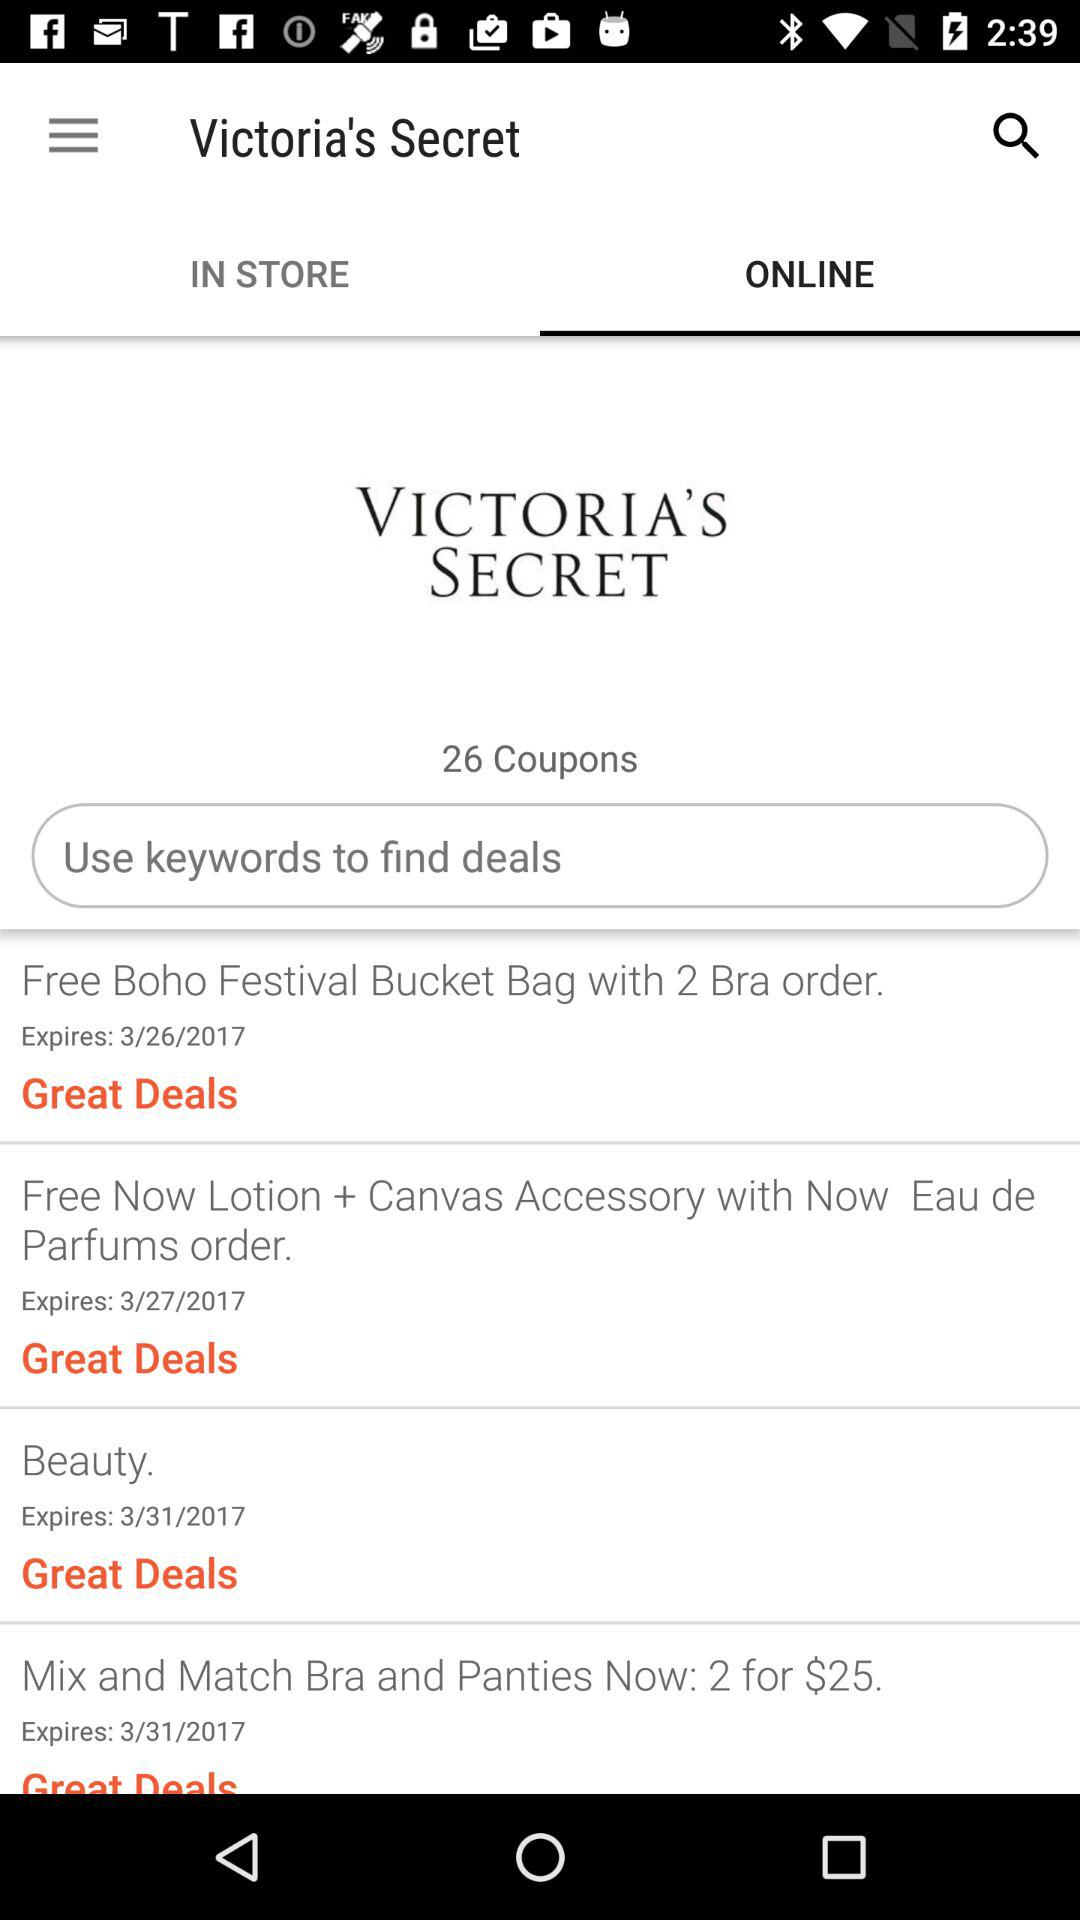How many coupons are there for Victoria's Secret?
Answer the question using a single word or phrase. 26 